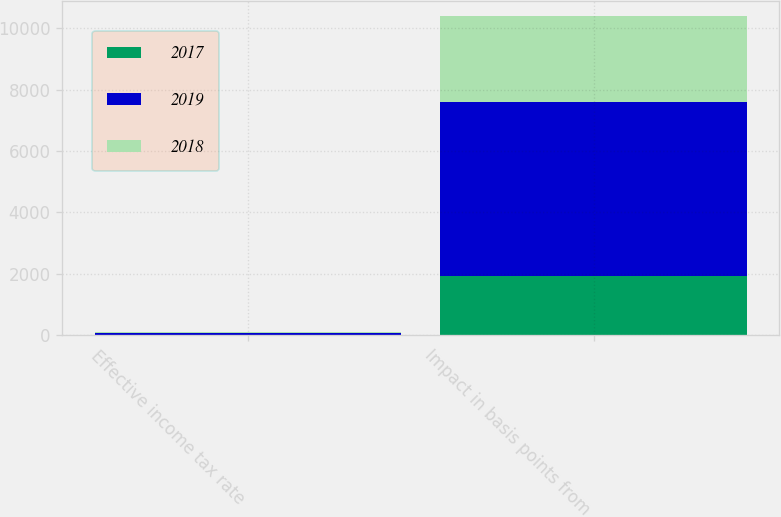Convert chart to OTSL. <chart><loc_0><loc_0><loc_500><loc_500><stacked_bar_chart><ecel><fcel>Effective income tax rate<fcel>Impact in basis points from<nl><fcel>2017<fcel>4.8<fcel>1920<nl><fcel>2019<fcel>73.5<fcel>5680<nl><fcel>2018<fcel>12.7<fcel>2790<nl></chart> 